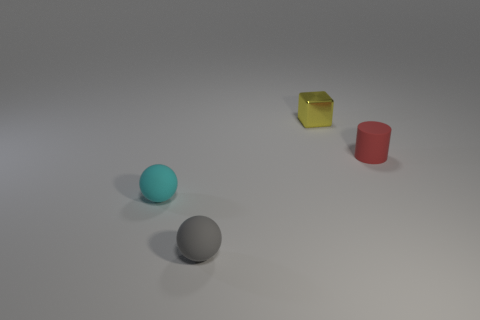Add 4 small cyan matte spheres. How many objects exist? 8 Subtract all cylinders. How many objects are left? 3 Add 2 small gray rubber objects. How many small gray rubber objects exist? 3 Subtract 0 brown cubes. How many objects are left? 4 Subtract all small gray balls. Subtract all big green metallic objects. How many objects are left? 3 Add 2 gray balls. How many gray balls are left? 3 